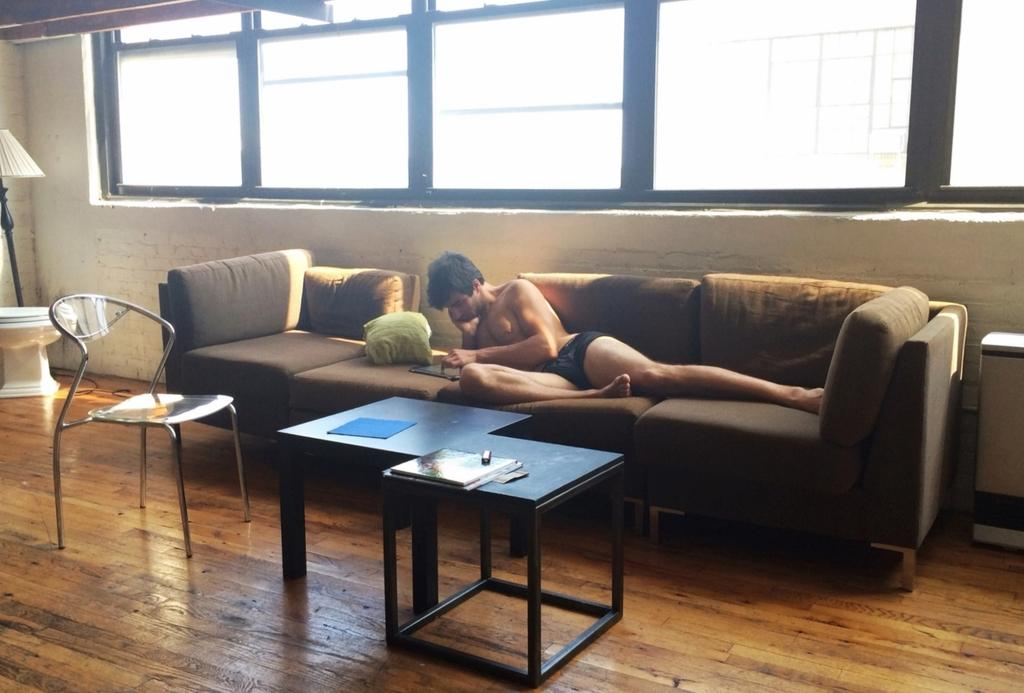What is the man in the image doing? The man is laying on the sofa in the image. What type of surface is visible beneath the man? The image contains a floor. What other piece of furniture is present in the image? There is a chair in the image. What object can be seen on a table in the image? There is a book on a table in the image. What light source is present in the image? There is a lamp in the image. What architectural feature is visible in the image? There is a window in the image. What type of dinosaurs can be seen roaming downtown in the image? There are no dinosaurs or downtown area present in the image. 